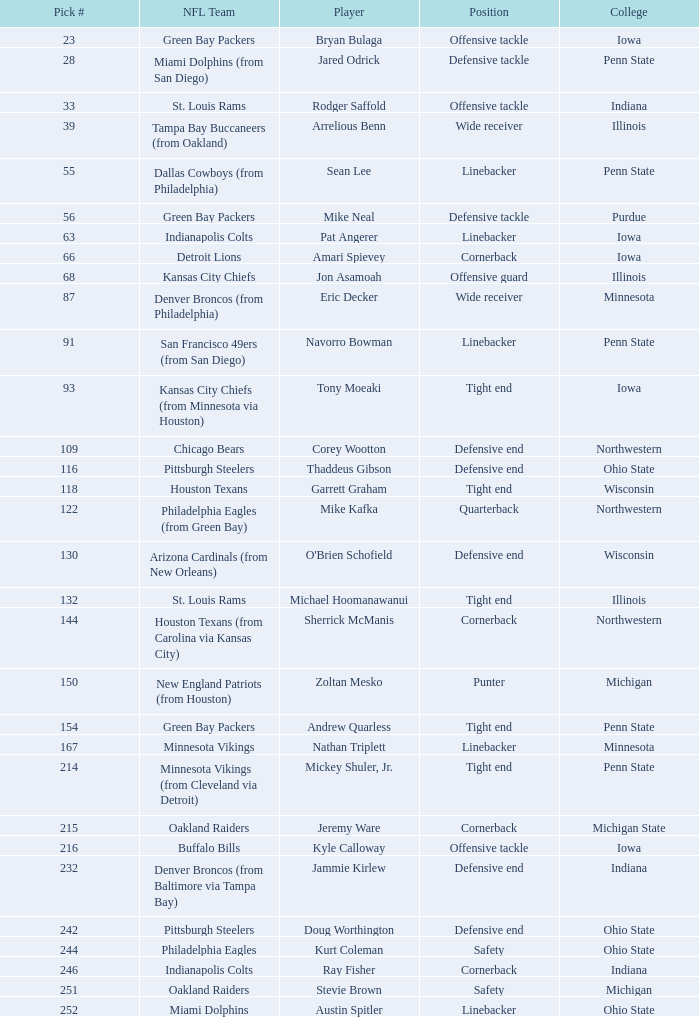On how many nfl teams does stevie brown perform? 1.0. 